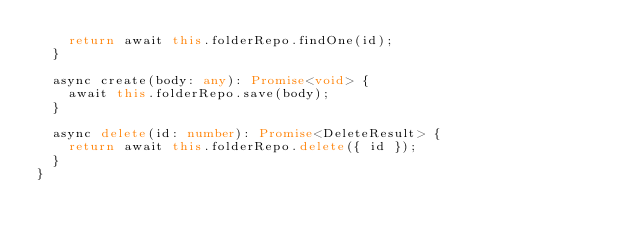Convert code to text. <code><loc_0><loc_0><loc_500><loc_500><_TypeScript_>    return await this.folderRepo.findOne(id);
  }

  async create(body: any): Promise<void> {
    await this.folderRepo.save(body);
  }

  async delete(id: number): Promise<DeleteResult> {
    return await this.folderRepo.delete({ id });
  }
}</code> 